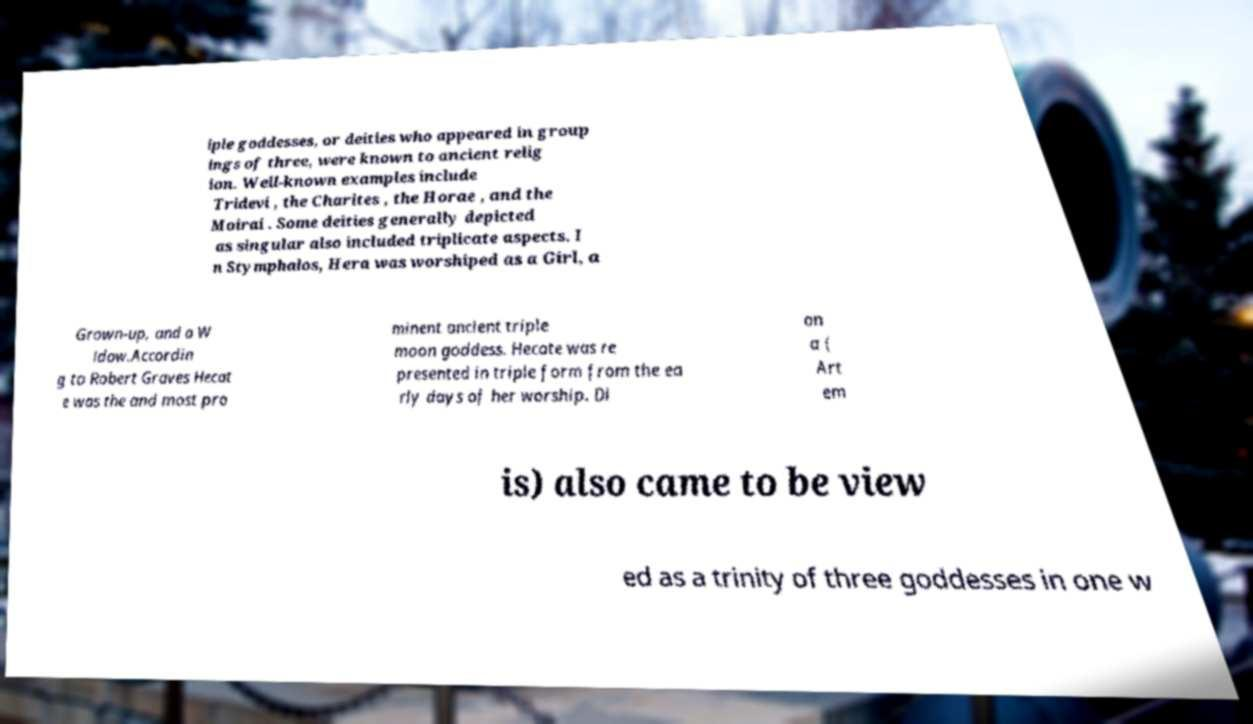Can you accurately transcribe the text from the provided image for me? iple goddesses, or deities who appeared in group ings of three, were known to ancient relig ion. Well-known examples include Tridevi , the Charites , the Horae , and the Moirai . Some deities generally depicted as singular also included triplicate aspects. I n Stymphalos, Hera was worshiped as a Girl, a Grown-up, and a W idow.Accordin g to Robert Graves Hecat e was the and most pro minent ancient triple moon goddess. Hecate was re presented in triple form from the ea rly days of her worship. Di an a ( Art em is) also came to be view ed as a trinity of three goddesses in one w 